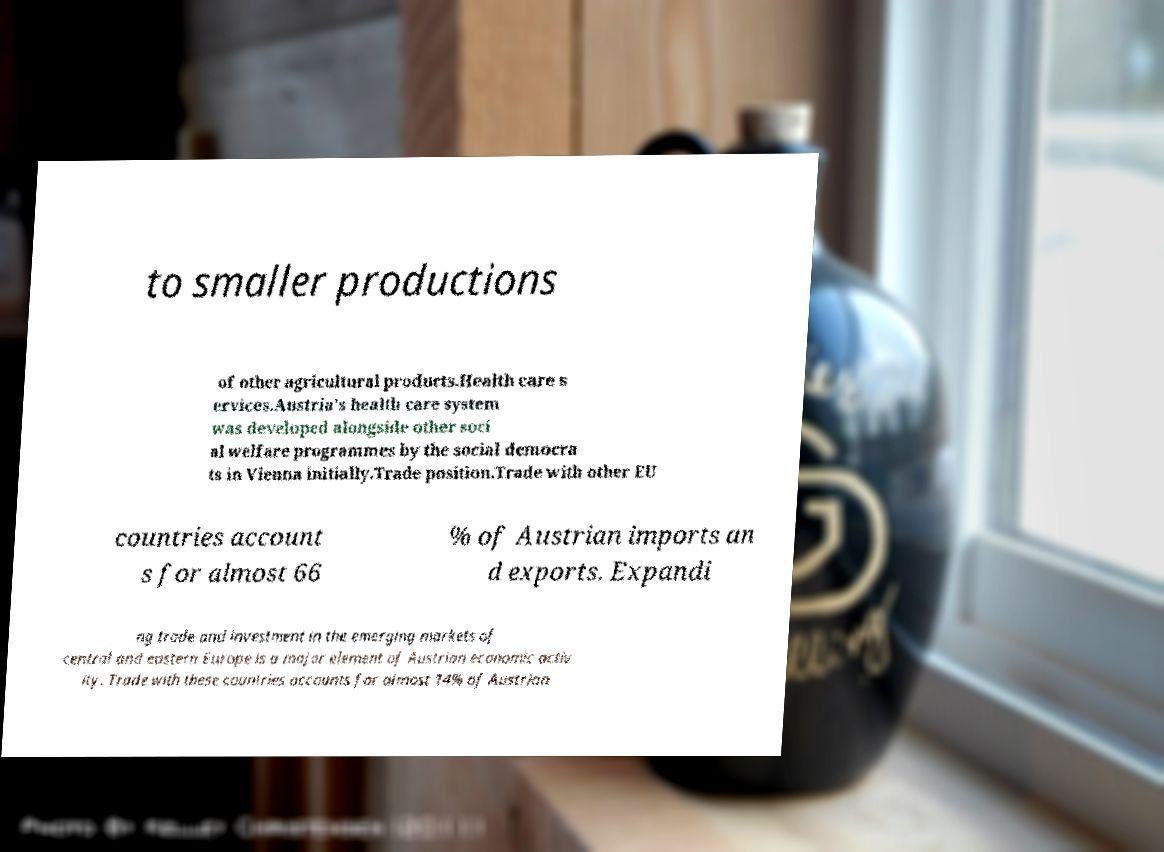Can you accurately transcribe the text from the provided image for me? to smaller productions of other agricultural products.Health care s ervices.Austria's health care system was developed alongside other soci al welfare programmes by the social democra ts in Vienna initially.Trade position.Trade with other EU countries account s for almost 66 % of Austrian imports an d exports. Expandi ng trade and investment in the emerging markets of central and eastern Europe is a major element of Austrian economic activ ity. Trade with these countries accounts for almost 14% of Austrian 